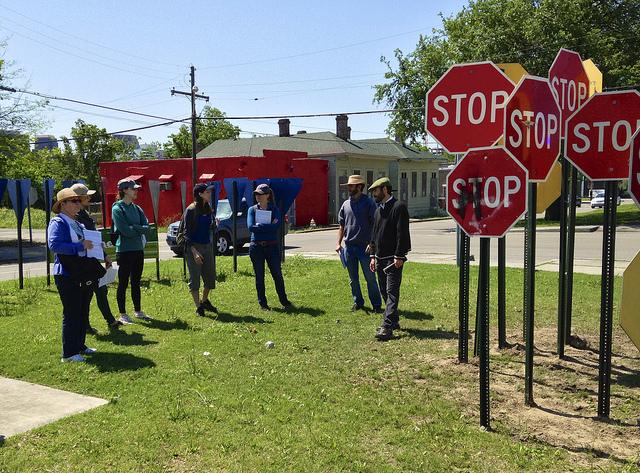What activity are the people doing?
Quick response, please. Standing. How many people are in this scene?
Be succinct. 7. How many stop signs are there?
Write a very short answer. 5. 